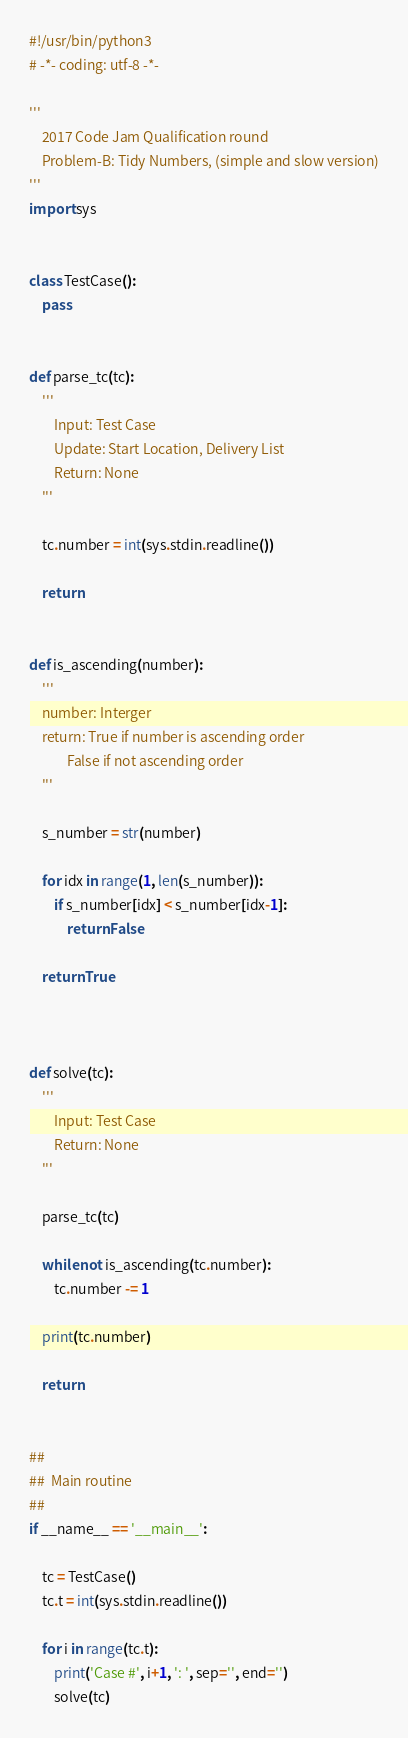Convert code to text. <code><loc_0><loc_0><loc_500><loc_500><_Python_>#!/usr/bin/python3
# -*- coding: utf-8 -*-

'''
    2017 Code Jam Qualification round
    Problem-B: Tidy Numbers, (simple and slow version)
'''
import sys


class TestCase():
    pass


def parse_tc(tc):
    '''
        Input: Test Case
        Update: Start Location, Delivery List
        Return: None
    '''

    tc.number = int(sys.stdin.readline())

    return


def is_ascending(number):
    '''
    number: Interger
    return: True if number is ascending order
            False if not ascending order
    '''

    s_number = str(number)

    for idx in range(1, len(s_number)):
        if s_number[idx] < s_number[idx-1]:
            return False

    return True



def solve(tc):
    '''
        Input: Test Case
        Return: None
    '''

    parse_tc(tc)

    while not is_ascending(tc.number):
        tc.number -= 1

    print(tc.number)

    return


##
##  Main routine
##
if __name__ == '__main__':

    tc = TestCase()
    tc.t = int(sys.stdin.readline())

    for i in range(tc.t):
        print('Case #', i+1, ': ', sep='', end='')
        solve(tc)
</code> 